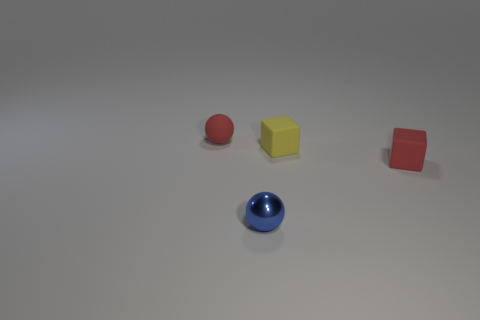Add 4 spheres. How many objects exist? 8 Subtract all tiny red rubber balls. Subtract all small blue objects. How many objects are left? 2 Add 3 tiny yellow cubes. How many tiny yellow cubes are left? 4 Add 2 shiny things. How many shiny things exist? 3 Subtract 0 brown spheres. How many objects are left? 4 